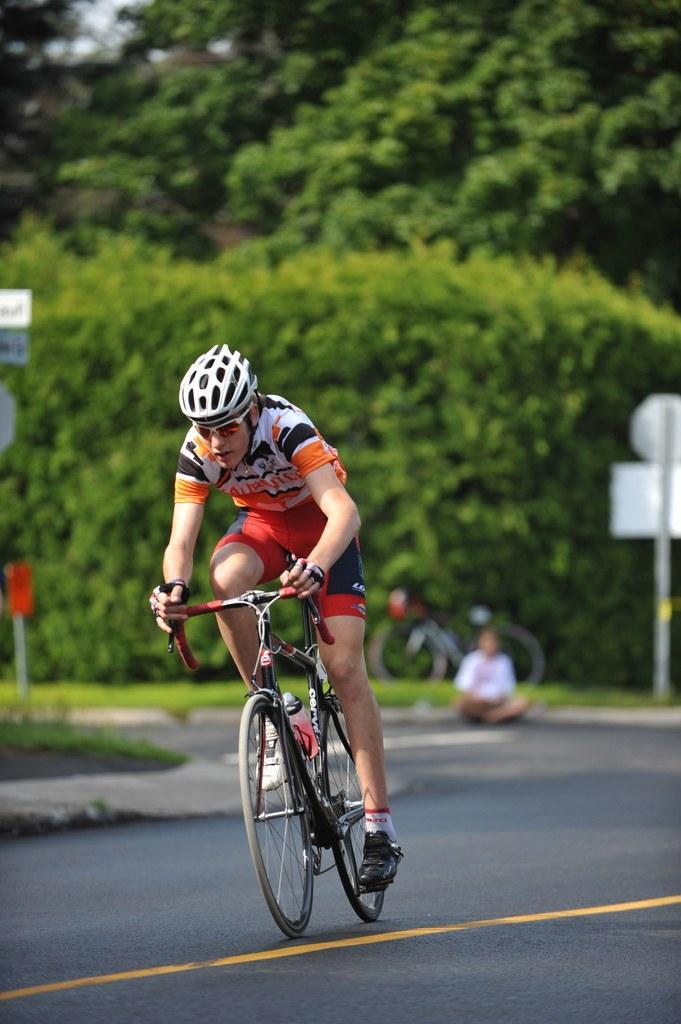How would you summarize this image in a sentence or two? This is the picture of a man riding a bicycle in the road and at the back ground we have a sign board ,a pole , a person and a bicycle and trees. 